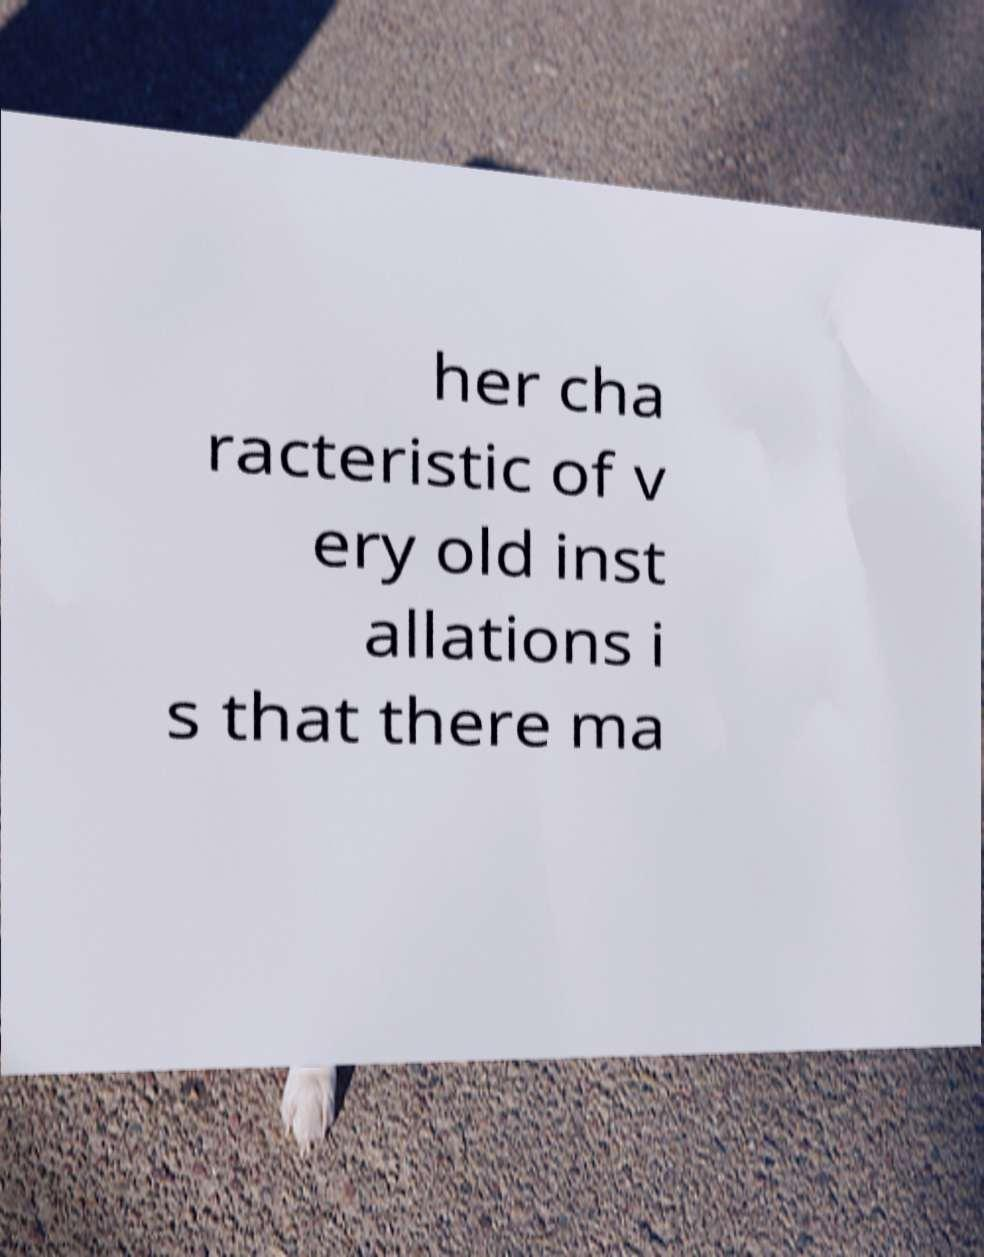Can you read and provide the text displayed in the image?This photo seems to have some interesting text. Can you extract and type it out for me? her cha racteristic of v ery old inst allations i s that there ma 